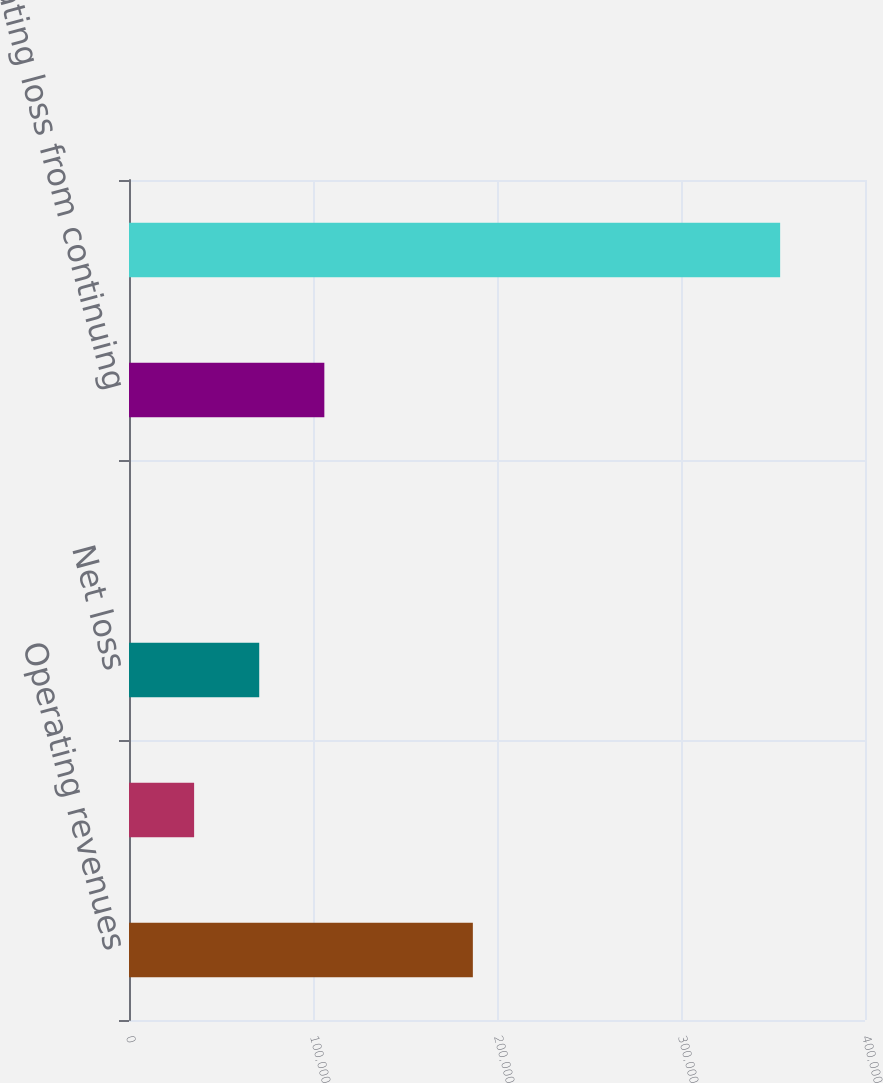<chart> <loc_0><loc_0><loc_500><loc_500><bar_chart><fcel>Operating revenues<fcel>Operating income from<fcel>Net loss<fcel>Basic and diluted loss per<fcel>Operating loss from continuing<fcel>Loss before cumulative effect<nl><fcel>186874<fcel>35387.9<fcel>70775.6<fcel>0.25<fcel>106163<fcel>353877<nl></chart> 